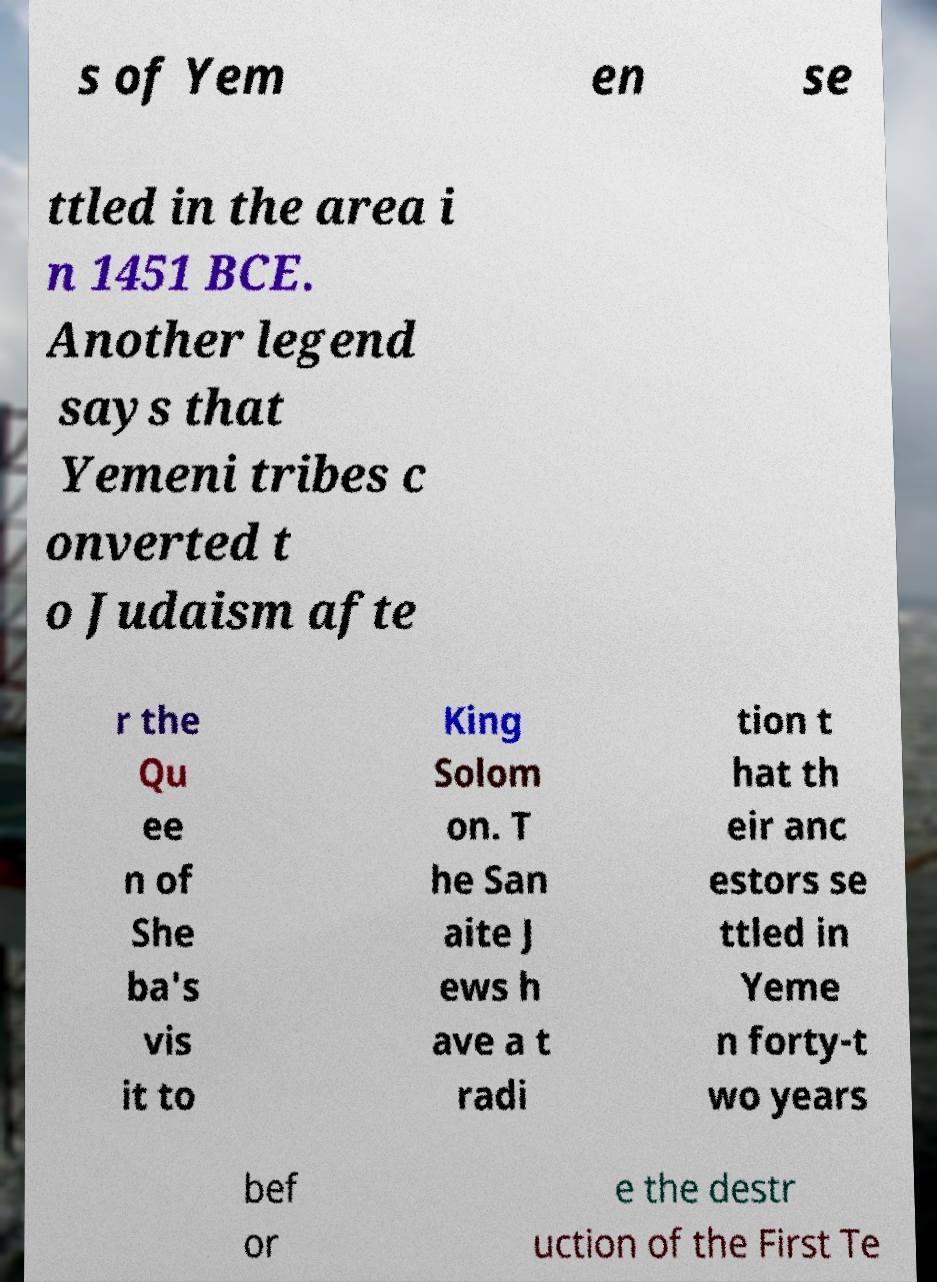I need the written content from this picture converted into text. Can you do that? s of Yem en se ttled in the area i n 1451 BCE. Another legend says that Yemeni tribes c onverted t o Judaism afte r the Qu ee n of She ba's vis it to King Solom on. T he San aite J ews h ave a t radi tion t hat th eir anc estors se ttled in Yeme n forty-t wo years bef or e the destr uction of the First Te 